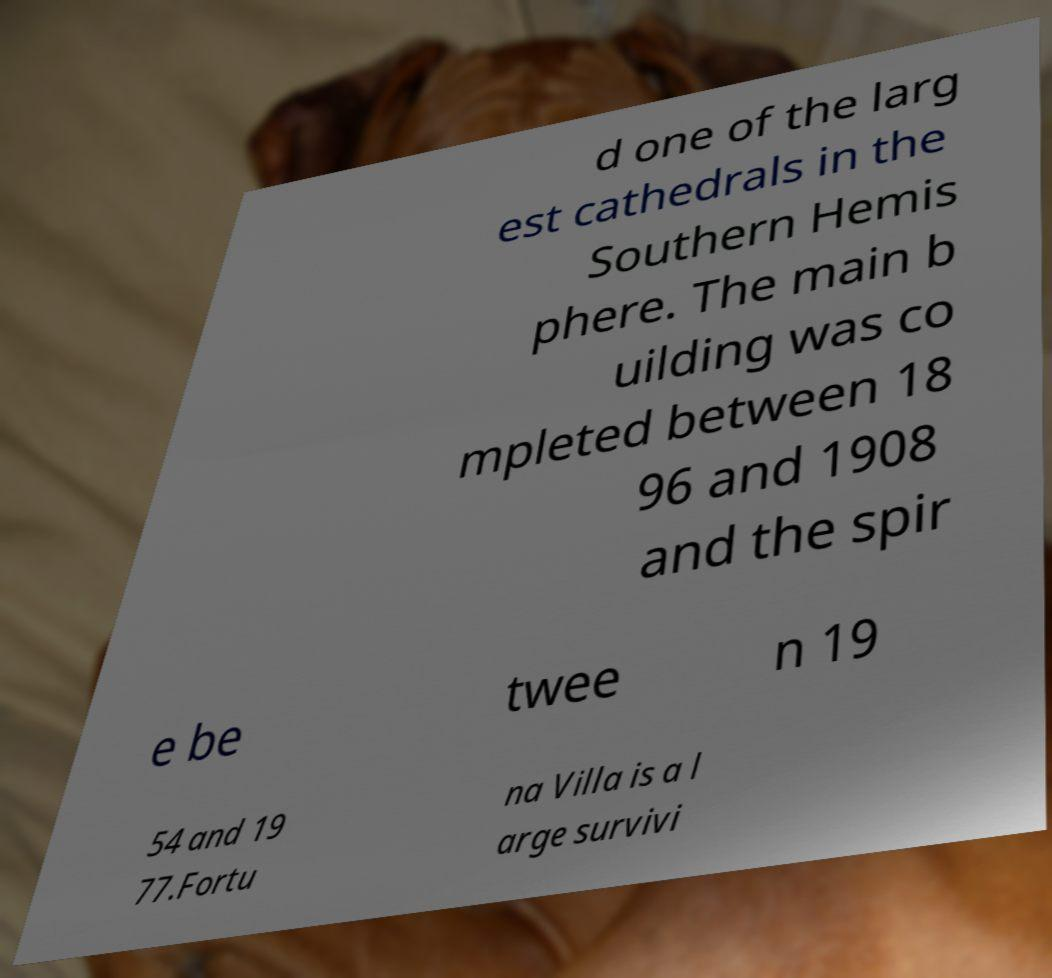Could you extract and type out the text from this image? d one of the larg est cathedrals in the Southern Hemis phere. The main b uilding was co mpleted between 18 96 and 1908 and the spir e be twee n 19 54 and 19 77.Fortu na Villa is a l arge survivi 